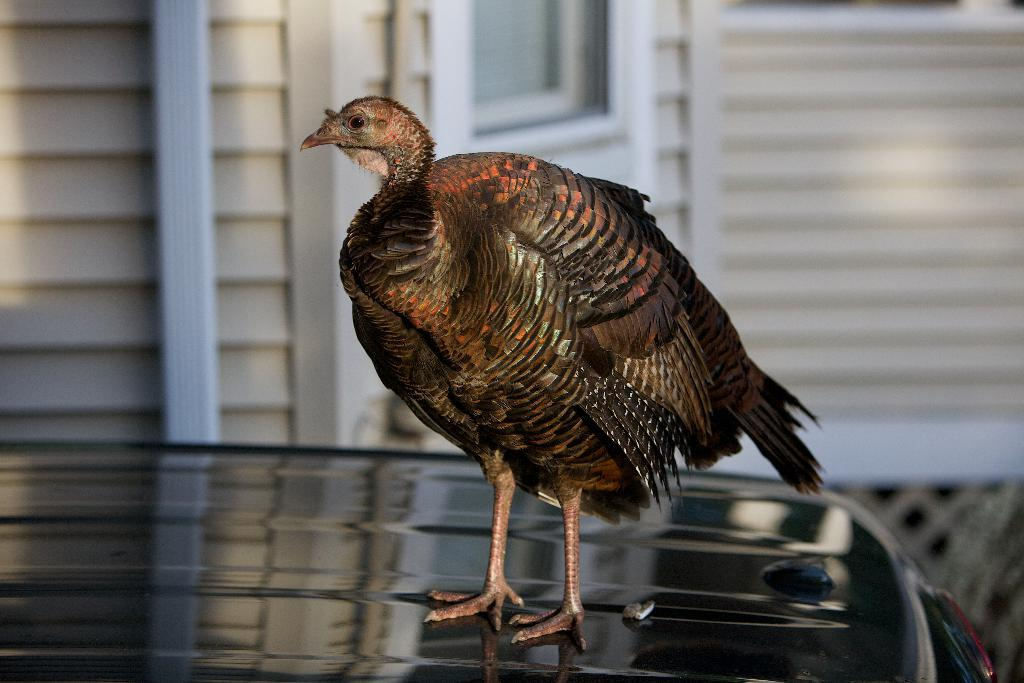What type of animal is in the image? There is a baby ostrich in the image. Where is the baby ostrich located? The baby ostrich is on a car. What can be seen in the background of the image? There is a window and a wall in the background of the image. What type of regret can be seen on the baby ostrich's face in the image? There is no indication of regret on the baby ostrich's face in the image, as it is a baby animal and does not have facial expressions that convey emotions like regret. 